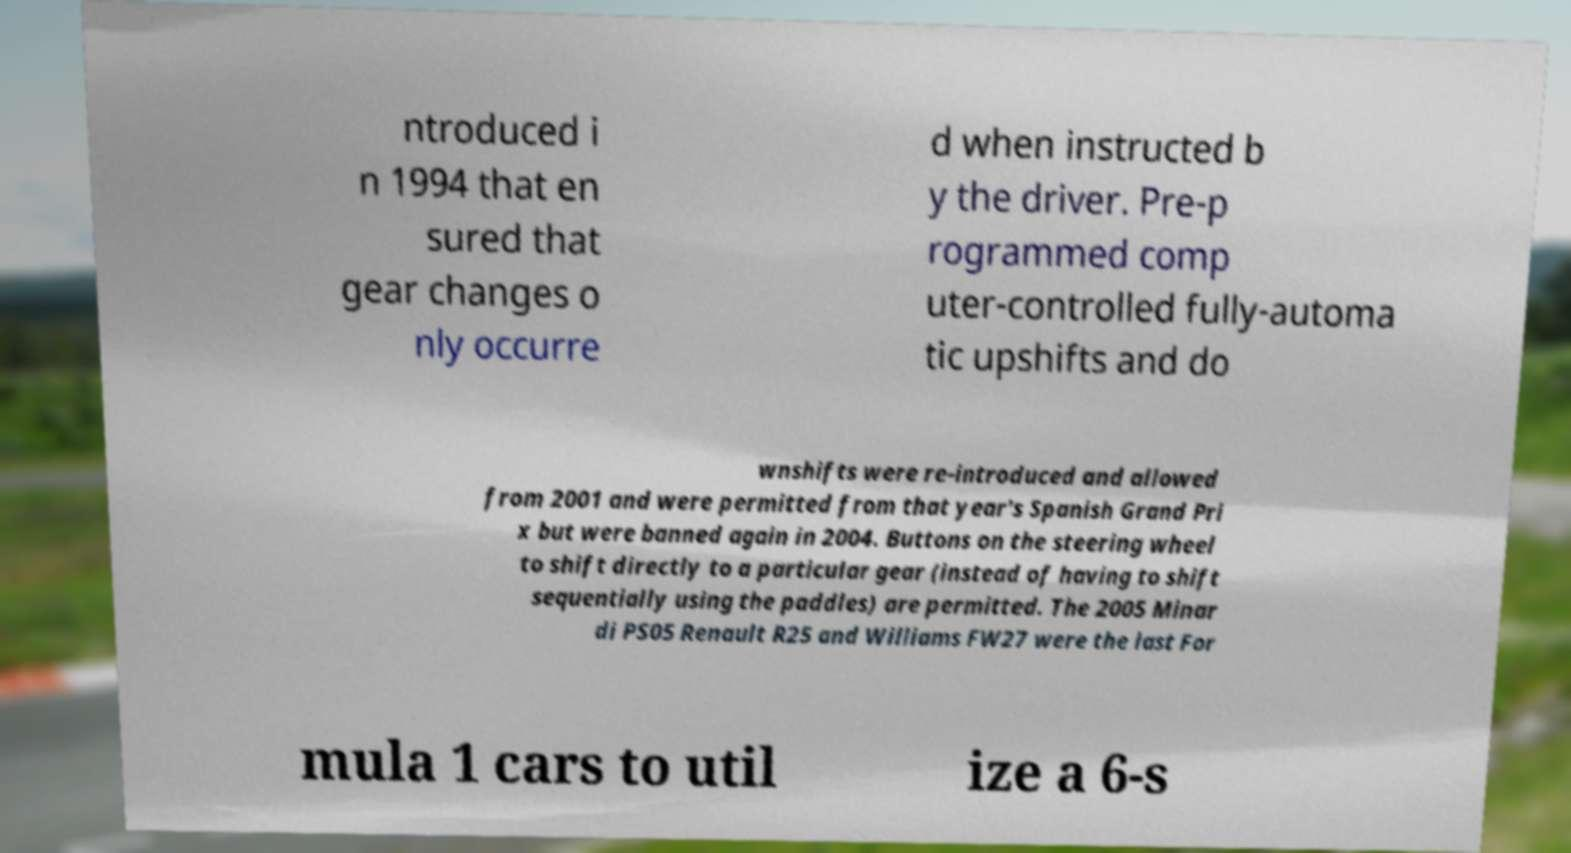Please read and relay the text visible in this image. What does it say? ntroduced i n 1994 that en sured that gear changes o nly occurre d when instructed b y the driver. Pre-p rogrammed comp uter-controlled fully-automa tic upshifts and do wnshifts were re-introduced and allowed from 2001 and were permitted from that year's Spanish Grand Pri x but were banned again in 2004. Buttons on the steering wheel to shift directly to a particular gear (instead of having to shift sequentially using the paddles) are permitted. The 2005 Minar di PS05 Renault R25 and Williams FW27 were the last For mula 1 cars to util ize a 6-s 